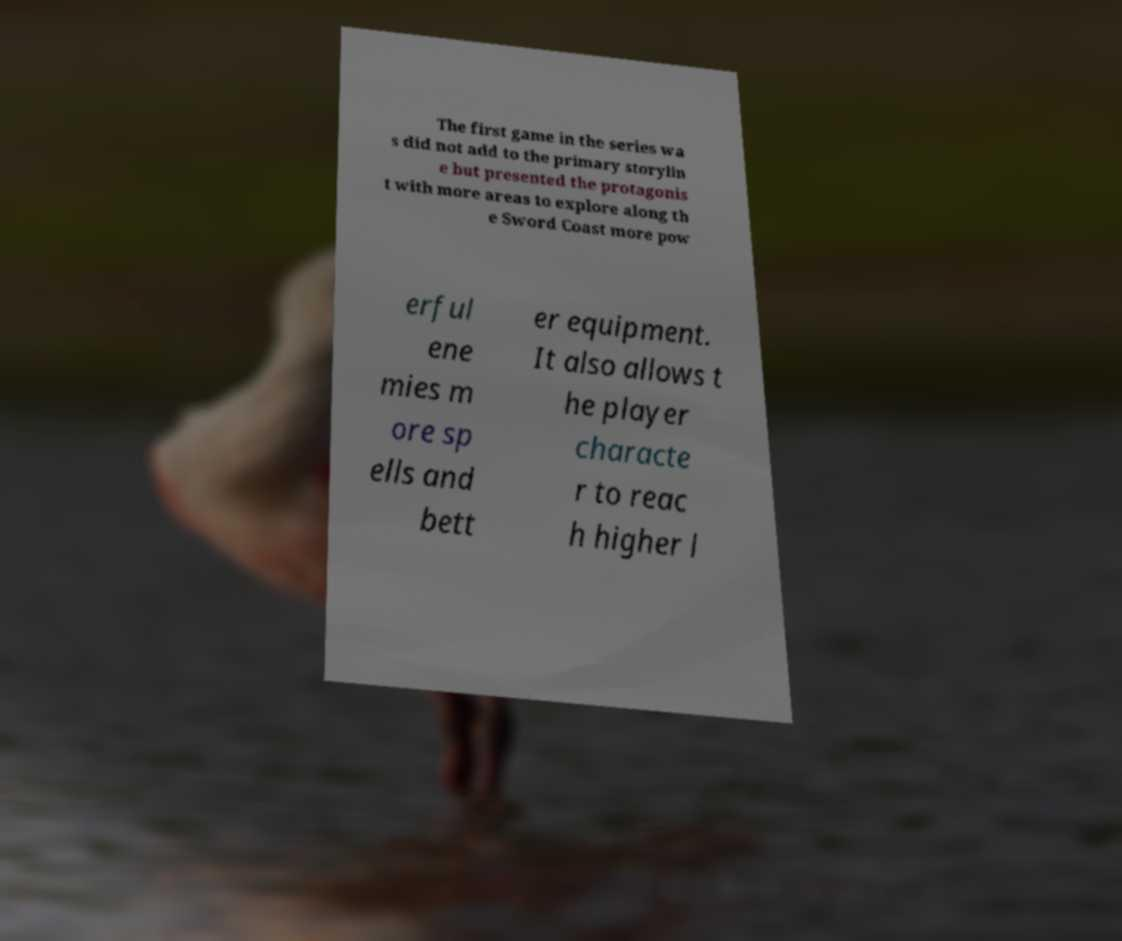Please read and relay the text visible in this image. What does it say? The first game in the series wa s did not add to the primary storylin e but presented the protagonis t with more areas to explore along th e Sword Coast more pow erful ene mies m ore sp ells and bett er equipment. It also allows t he player characte r to reac h higher l 